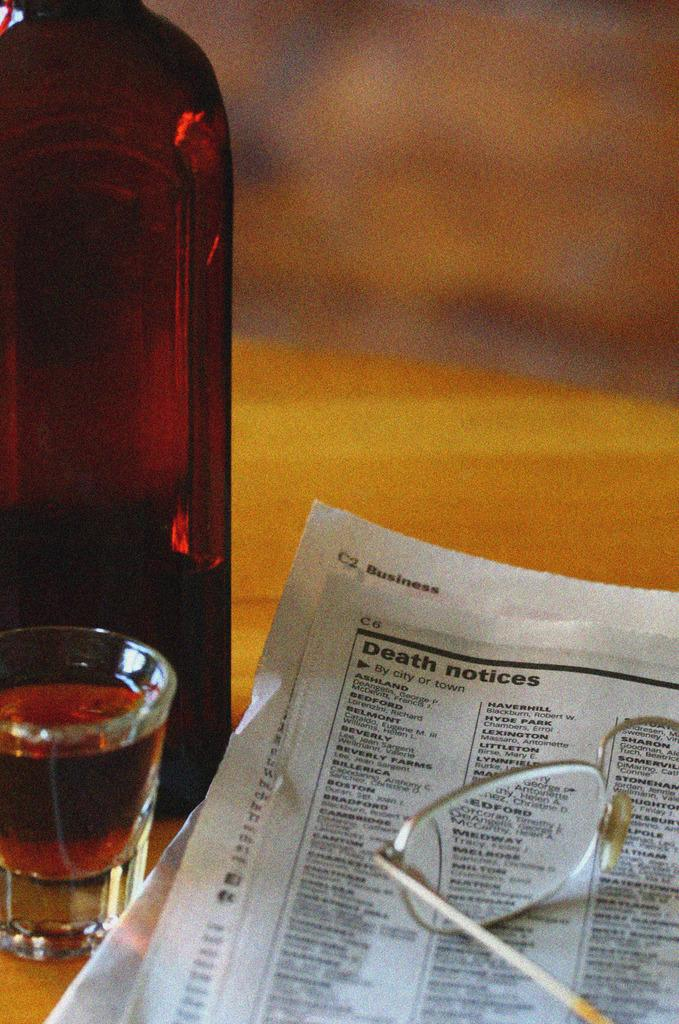Provide a one-sentence caption for the provided image. A shot glass full of liquid sits beside the Obituaries in the paper with a set of glass frames on top. 